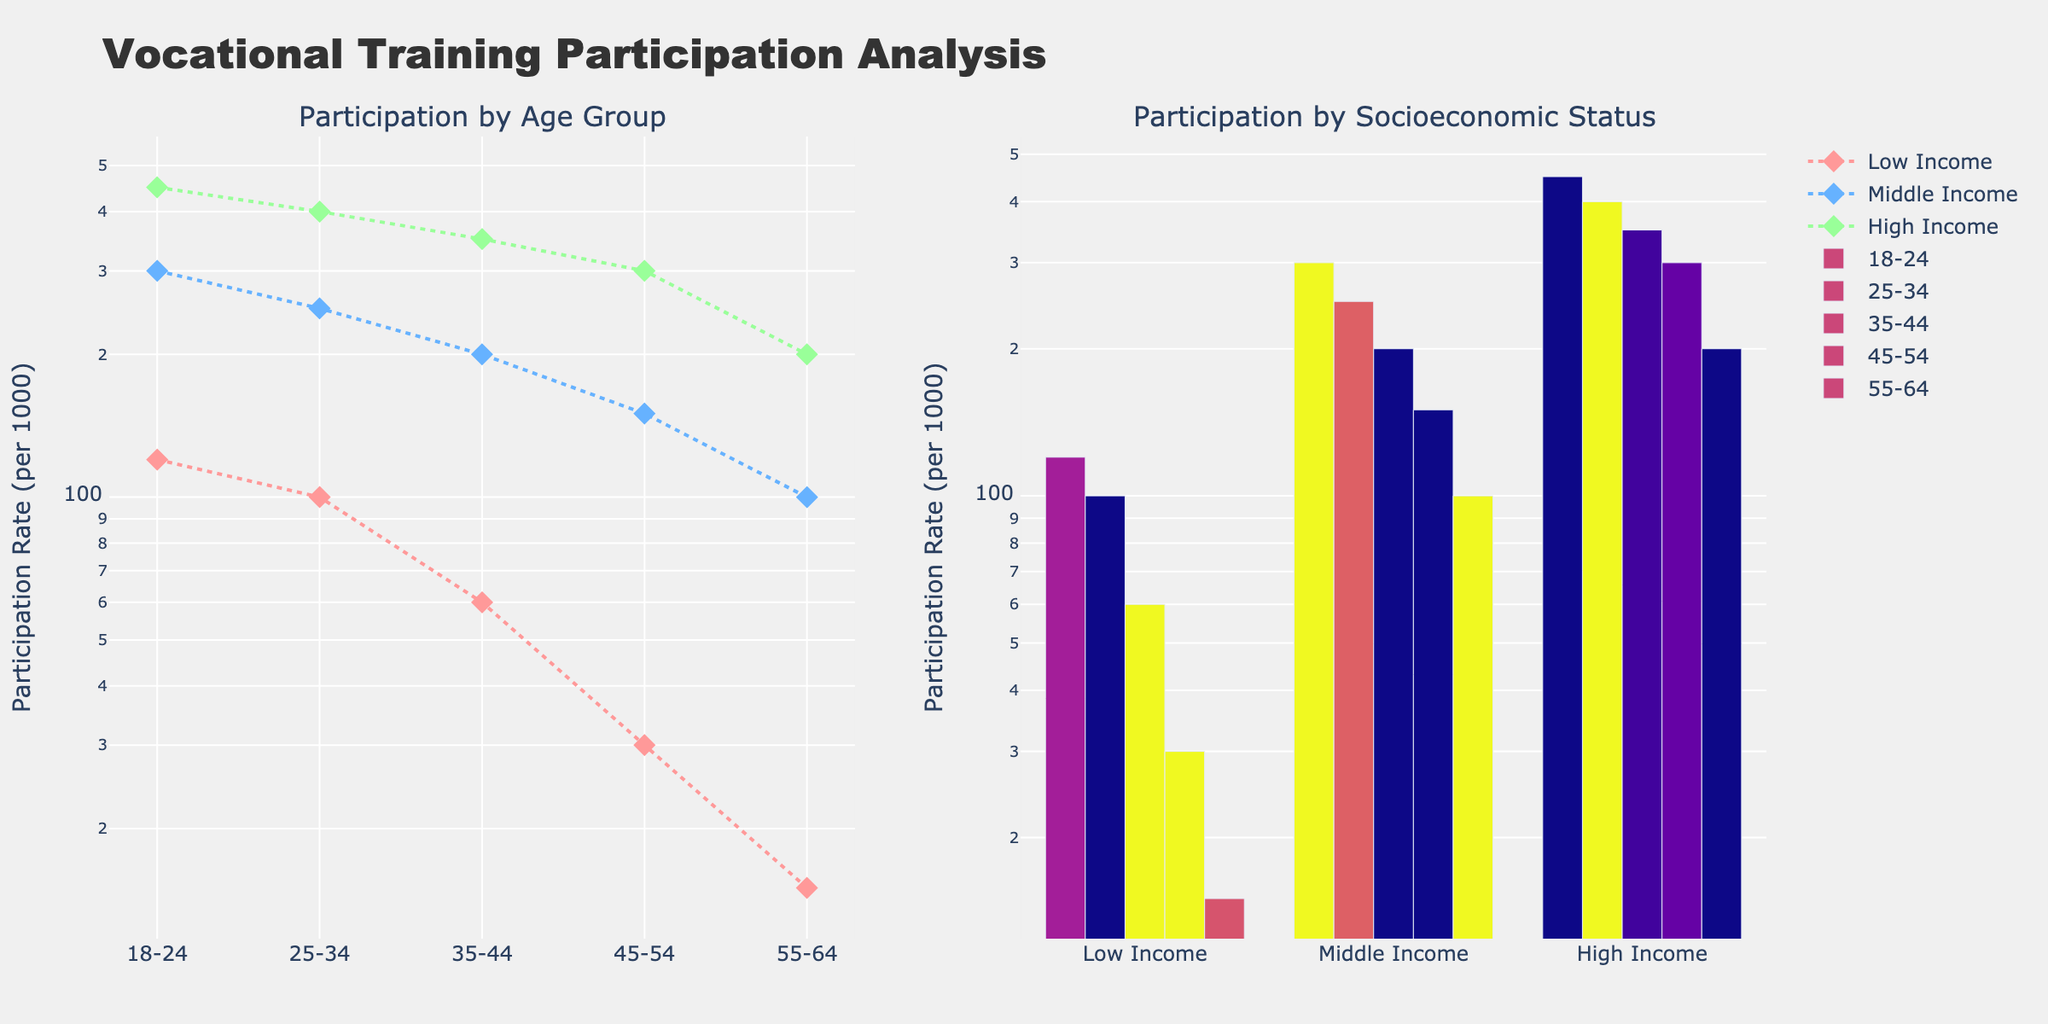How many different age groups are shown in the plot? There are distinct age groups displayed in the x-axis of both subplots. These groups are visibly labelled. By counting the labels, we can see there are five age groups: 18-24, 25-34, 35-44, 45-54, and 55-64.
Answer: 5 What is the participation rate for the high-income group in the 35-44 age bracket? Look at the first subplot, locate the 35-44 age bracket on the x-axis, and find the line corresponding to the high-income group (indicated by the green color). The y-axis value for this point indicates a participation rate of 350.
Answer: 350 Which socioeconomic status shows the most variability in participation rates across different age groups? In the first subplot, we observe the three lines corresponding to different socioeconomic statuses across age groups. The High Income line shows the widest range of y-values (450 to 200) indicating the most variability.
Answer: High Income At what age group does the middle-income group's participation rate drop below 100 per 1000? In the first subplot, find the Middle Income line (blue) and follow it along the age groups. The rate drops below 100 per 1000 at the 55-64 age group.
Answer: 55-64 Compare the participation rates of low-income and high-income groups in the 45-54 age bracket. In the first subplot, find the 45-54 age group on the x-axis. The points for Low Income (red) and High Income (green) indicate rates of 30 and 300 respectively. Therefore, the high-income group's participation rate is significantly higher than the low-income group's.
Answer: High Income is higher What is the rate difference between middle-income and high-income groups in the 25-34 age bracket? In the first subplot, locate 25-34 on the x-axis. The y-values for Middle Income and High Income are 250 and 400, respectively. The difference is 400 - 250 = 150.
Answer: 150 What pattern can be observed in the participation rates of the low-income group across age groups? Observe the Low Income line (red) in the first subplot. The participation rates consistently decline as age increases, showing a downward trend from 120 to 15.
Answer: Declining How does participation by socioeconomic status vary in the 18-24 age group? In the second subplot, locate the bars corresponding to the 18-24 age group on the x-axis. Compare the heights of bars for Low, Middle, and High Income: 120, 300, 450 respectively. High Income has the highest participation, followed by Middle and Low Income.
Answer: High > Middle > Low Which age group has the highest participation rate for low-income individuals? In the first subplot, find the highest y-value for the red line. This occurs at the 18-24 age group, with a rate of 120.
Answer: 18-24 